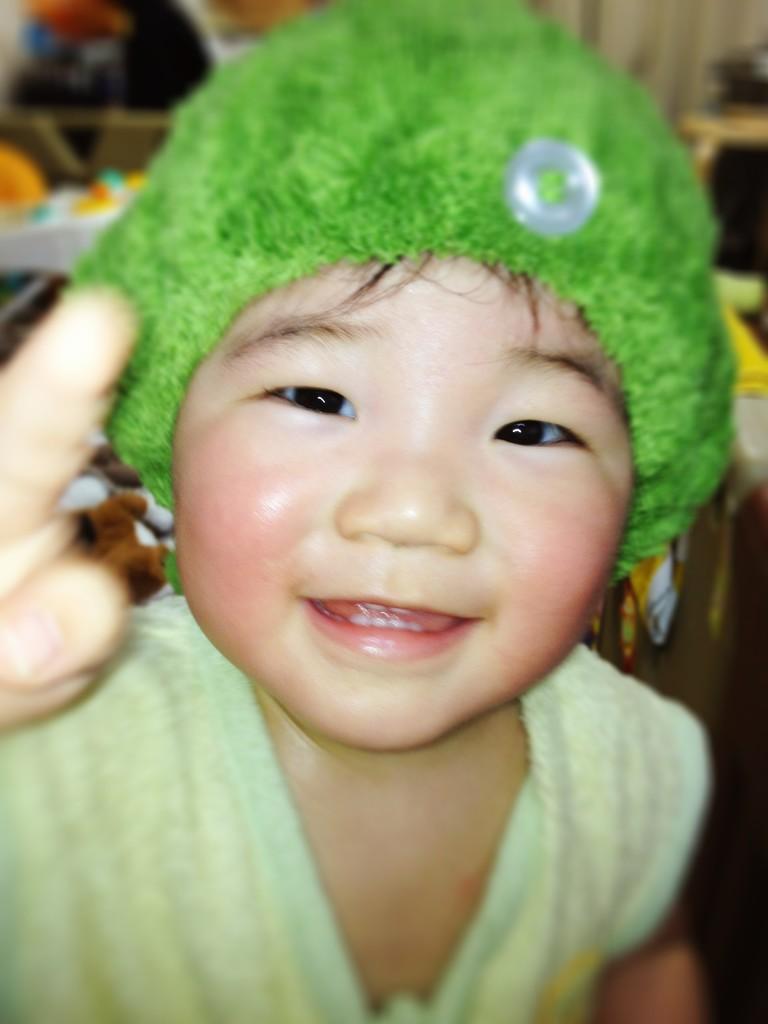How would you summarize this image in a sentence or two? In the image I can see a child in green cap and green dress. 